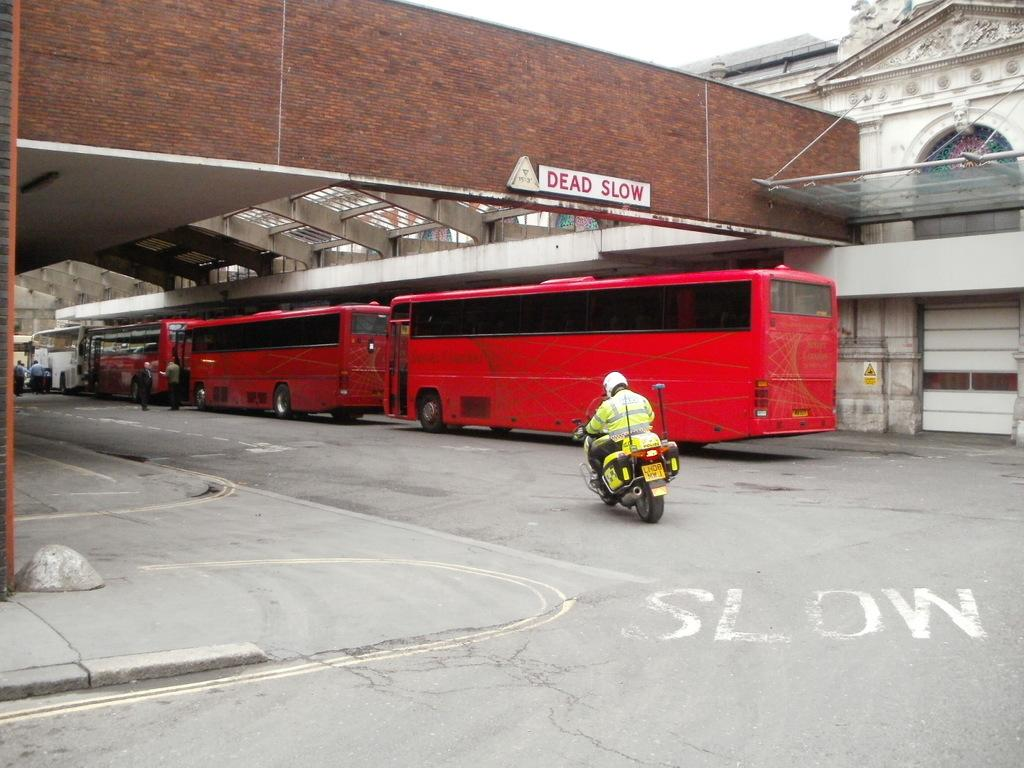What is the person in the image doing? The person is sitting and riding a vehicle. What type of vehicles can be seen on the road? Buses are visible on the road. What can be seen in the background of the image? There are people, a building, and the sky visible in the background of the image. Is there any signage or noticeable object on a wall in the background? Yes, there is a board on a wall in the background of the image. What type of liquid is being poured into the cup in the image? There is no cup or liquid present in the image. What type of hat is the person wearing in the image? The person in the image is not wearing a hat. 